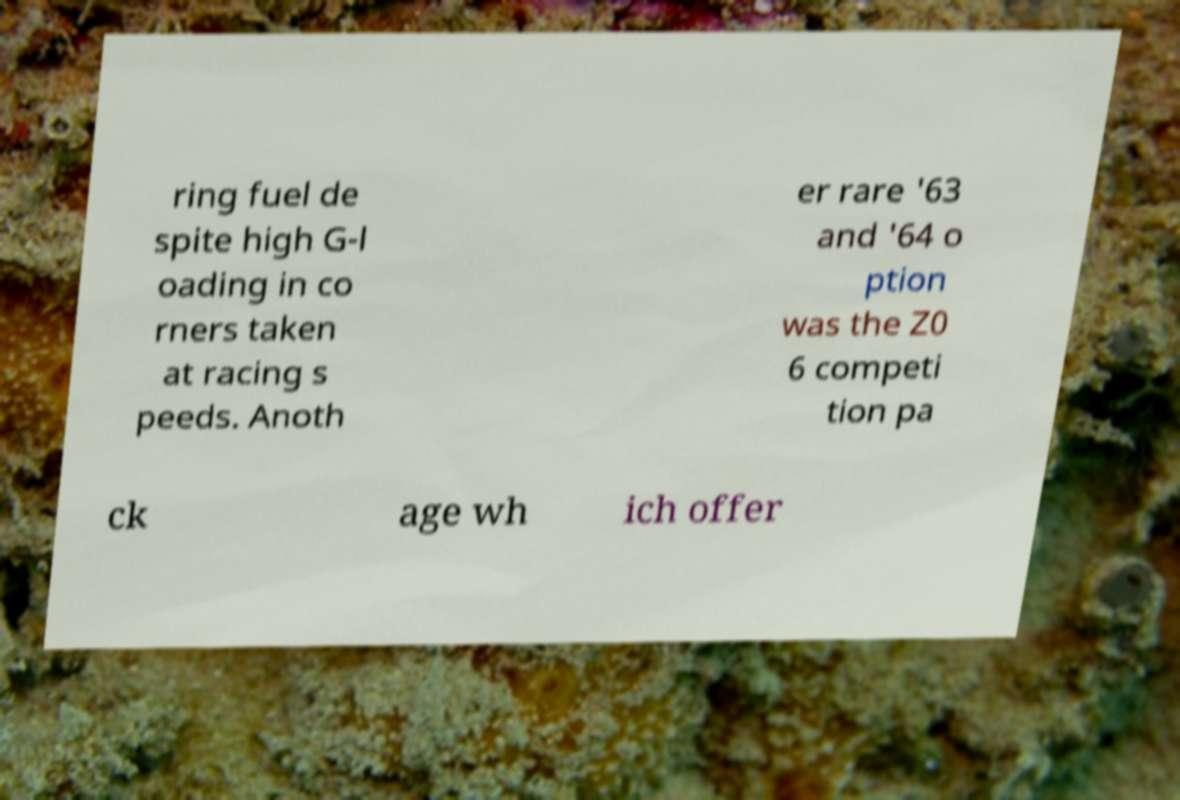For documentation purposes, I need the text within this image transcribed. Could you provide that? ring fuel de spite high G-l oading in co rners taken at racing s peeds. Anoth er rare '63 and '64 o ption was the Z0 6 competi tion pa ck age wh ich offer 